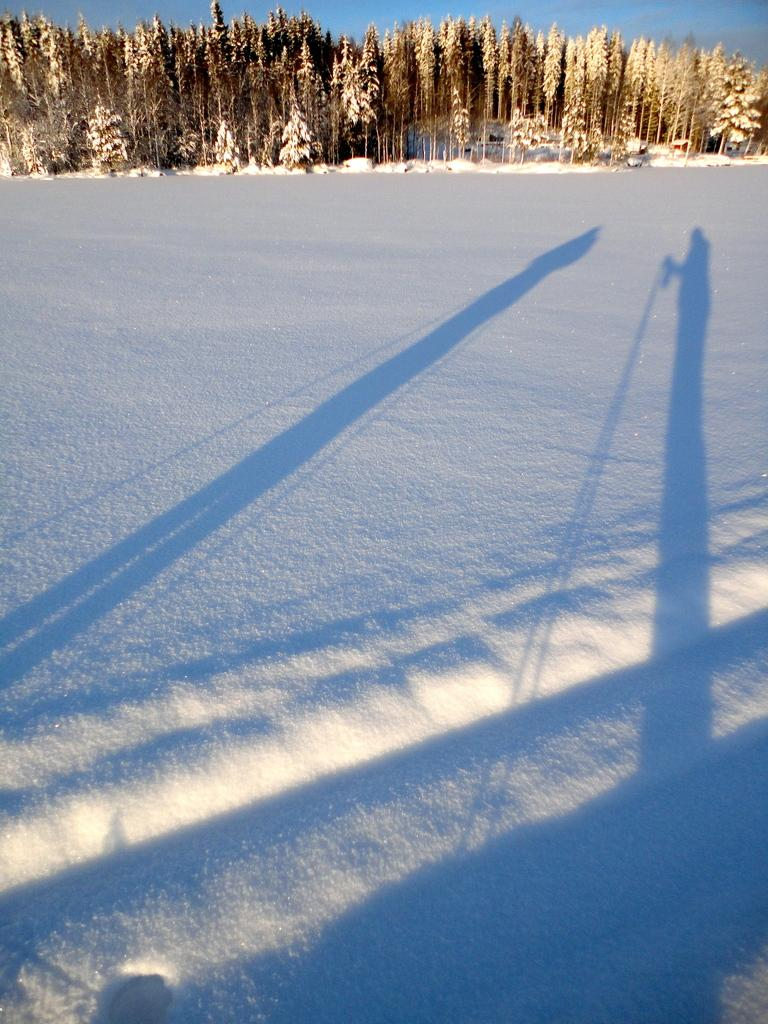What type of weather condition is depicted in the image? There is snow in the image, indicating a cold or wintry weather condition. What can be seen in the background of the image? There are plants visible in the background of the image. What color is the sky in the image? The sky is blue in the image. Who is the daughter of the person helping with the credit in the image? There is no person, credit, or daughter mentioned in the image; it only depicts snow, plants, and a blue sky. 